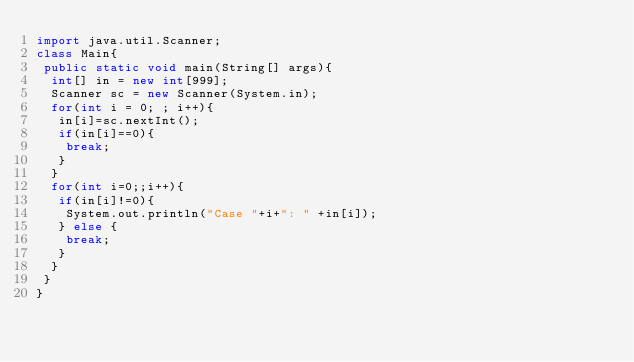Convert code to text. <code><loc_0><loc_0><loc_500><loc_500><_Java_>import java.util.Scanner;
class Main{
 public static void main(String[] args){
  int[] in = new int[999];
  Scanner sc = new Scanner(System.in);
  for(int i = 0; ; i++){
   in[i]=sc.nextInt();
   if(in[i]==0){
    break;
   }
  }
  for(int i=0;;i++){
   if(in[i]!=0){
    System.out.println("Case "+i+": " +in[i]);
   } else {
    break;
   }
  }
 }
}</code> 